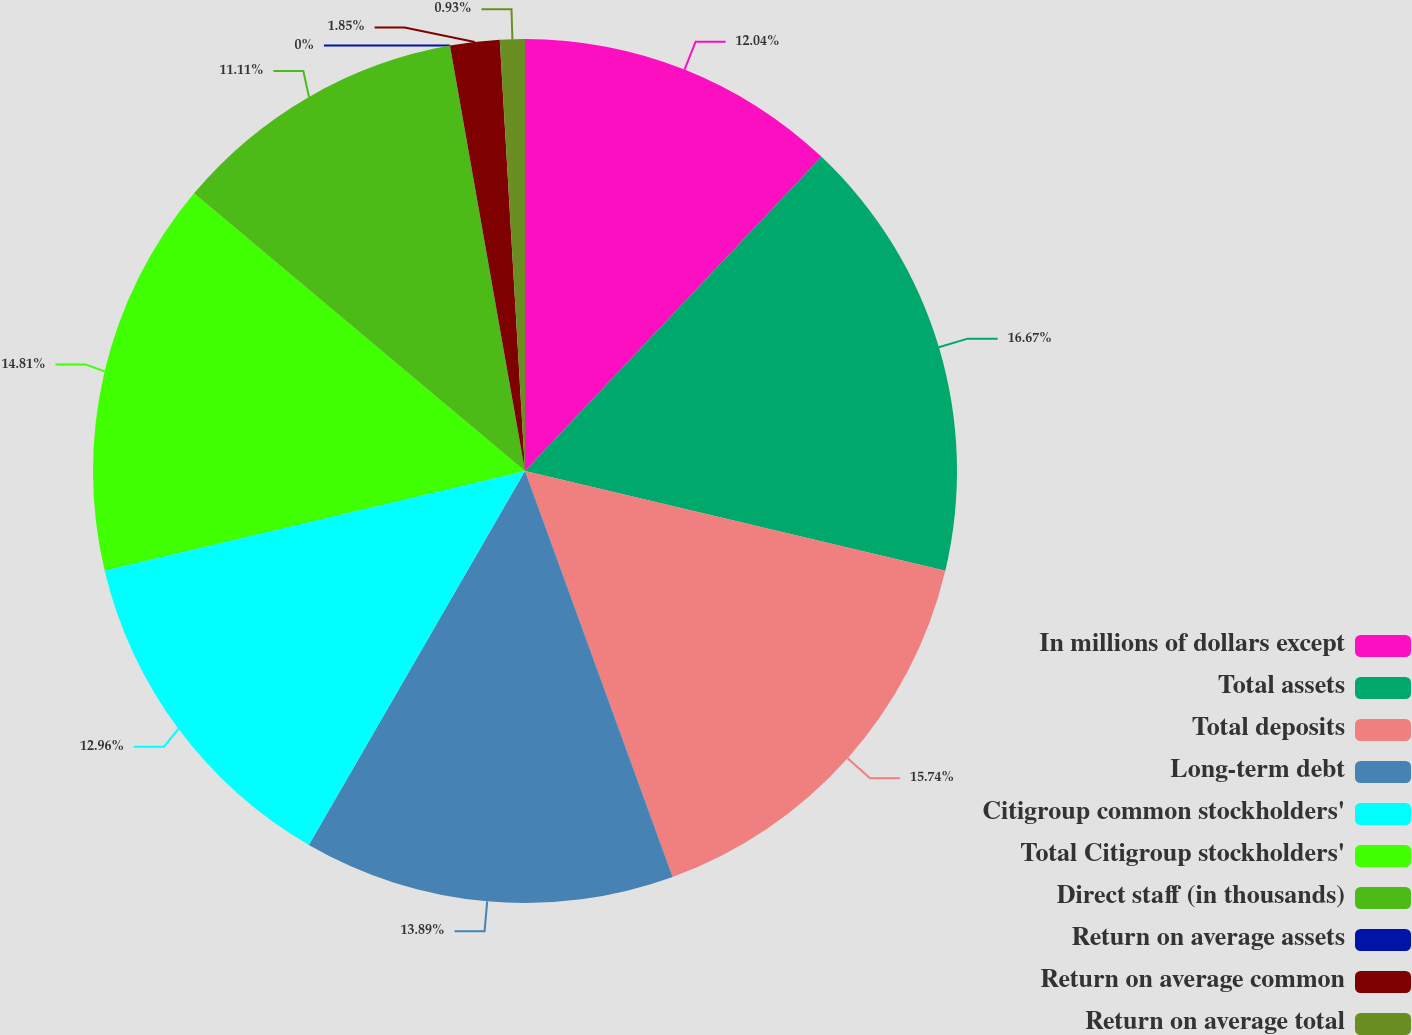<chart> <loc_0><loc_0><loc_500><loc_500><pie_chart><fcel>In millions of dollars except<fcel>Total assets<fcel>Total deposits<fcel>Long-term debt<fcel>Citigroup common stockholders'<fcel>Total Citigroup stockholders'<fcel>Direct staff (in thousands)<fcel>Return on average assets<fcel>Return on average common<fcel>Return on average total<nl><fcel>12.04%<fcel>16.67%<fcel>15.74%<fcel>13.89%<fcel>12.96%<fcel>14.81%<fcel>11.11%<fcel>0.0%<fcel>1.85%<fcel>0.93%<nl></chart> 